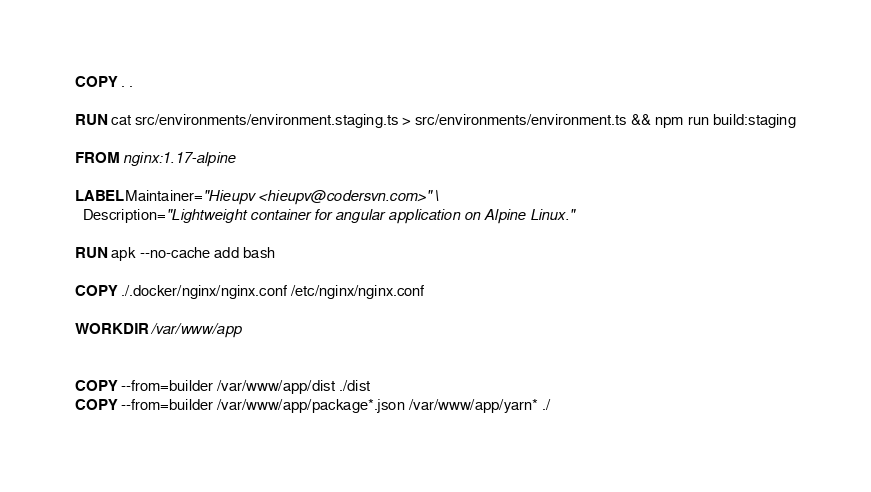Convert code to text. <code><loc_0><loc_0><loc_500><loc_500><_Dockerfile_>COPY . .

RUN cat src/environments/environment.staging.ts > src/environments/environment.ts && npm run build:staging

FROM nginx:1.17-alpine

LABEL Maintainer="Hieupv <hieupv@codersvn.com>" \
  Description="Lightweight container for angular application on Alpine Linux."

RUN apk --no-cache add bash

COPY ./.docker/nginx/nginx.conf /etc/nginx/nginx.conf

WORKDIR /var/www/app


COPY --from=builder /var/www/app/dist ./dist
COPY --from=builder /var/www/app/package*.json /var/www/app/yarn* ./
</code> 